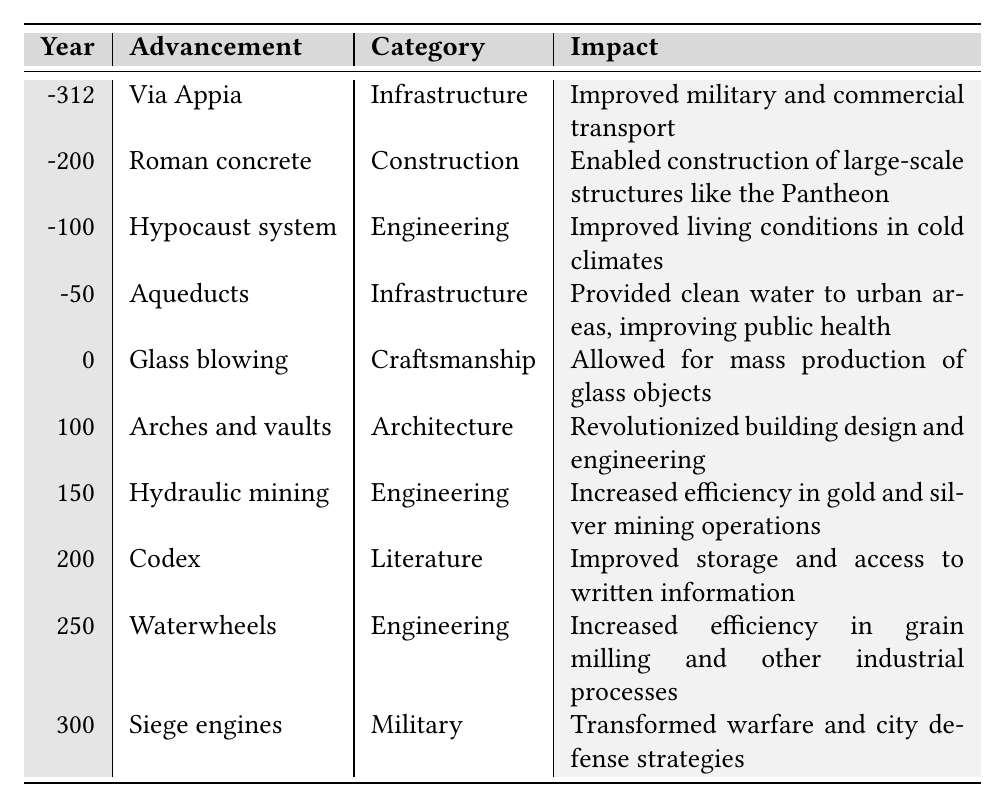What major technological advancement was made in -50? According to the table, the major technological advancement in -50 is "Aqueducts".
Answer: Aqueducts What was the impact of Roman concrete? The table states that the impact of Roman concrete was that it enabled the construction of large-scale structures like the Pantheon.
Answer: Enabled large-scale construction Which category does glass blowing fall under? By looking at the table, glass blowing is categorized under "Craftsmanship".
Answer: Craftsmanship Was the hypocaust system developed before or after the year 0? The hypocaust system was developed in the year -100, which is before the year 0.
Answer: Before What is the difference in years between the invention of hydraulic mining and the invention of waterwheels? Hydraulic mining was invented in 150, while waterwheels were invented in 250. The difference is 250 - 150 = 100 years.
Answer: 100 years Which advancement is associated with improved public health? The table indicates that aqueducts provided clean water to urban areas and improved public health.
Answer: Aqueducts How many advancements in the Engineering category are included in the table? The table lists three advancements in the Engineering category: Hypocaust system, Hydraulic mining, and Waterwheels.
Answer: 3 advancements Which advancement had the earliest date associated with it? The earliest date is -312, which corresponds to "Via Appia".
Answer: Via Appia What advancements occurred in the 100-200 year range and their impacts? The advancements are "Arches and vaults" in 100 and "Codex" in 200. Arches and vaults revolutionized building design, and the Codex improved storage and access to information.
Answer: Arches and vaults; Codex Are siege engines categorized as Infrastructure? No, the table categorizes siege engines as Military, not Infrastructure.
Answer: No 